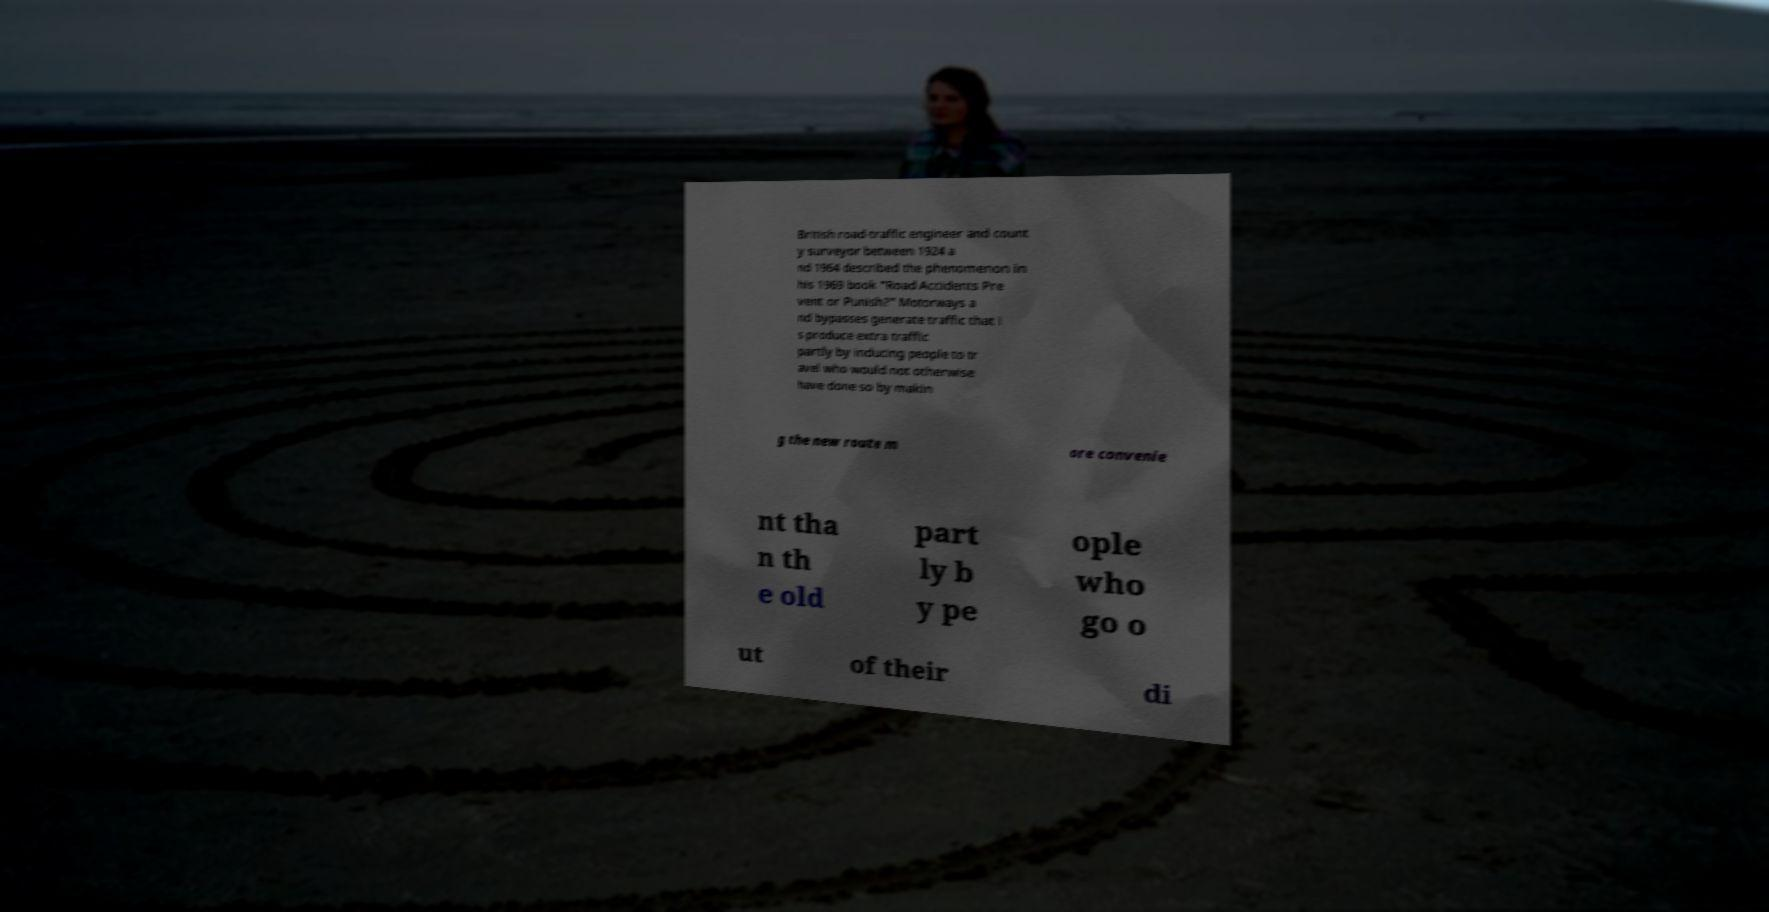There's text embedded in this image that I need extracted. Can you transcribe it verbatim? British road-traffic engineer and count y surveyor between 1924 a nd 1964 described the phenomenon in his 1969 book "Road Accidents Pre vent or Punish?" Motorways a nd bypasses generate traffic that i s produce extra traffic partly by inducing people to tr avel who would not otherwise have done so by makin g the new route m ore convenie nt tha n th e old part ly b y pe ople who go o ut of their di 